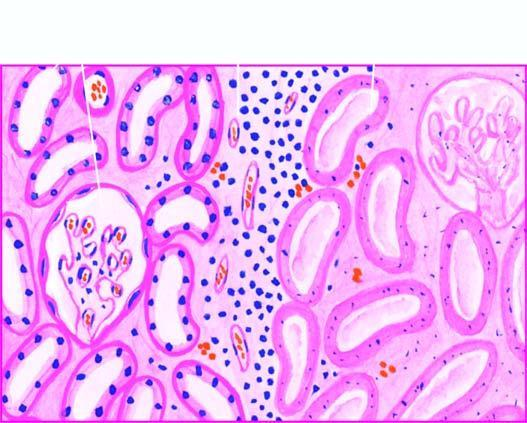does necrosis show cells with intensely eosinophilic cytoplasm of tubular cells?
Answer the question using a single word or phrase. No 